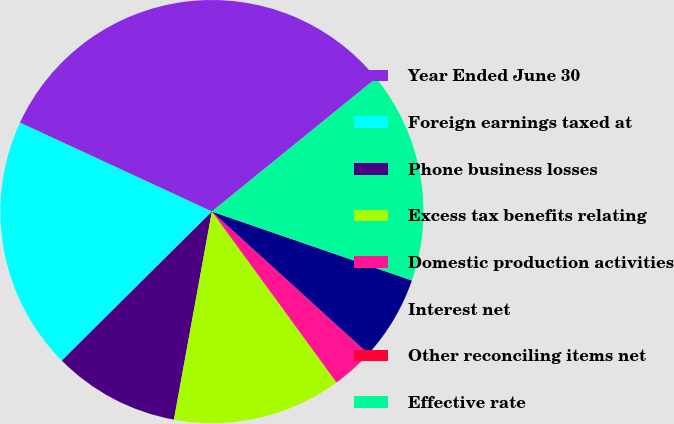<chart> <loc_0><loc_0><loc_500><loc_500><pie_chart><fcel>Year Ended June 30<fcel>Foreign earnings taxed at<fcel>Phone business losses<fcel>Excess tax benefits relating<fcel>Domestic production activities<fcel>Interest net<fcel>Other reconciling items net<fcel>Effective rate<nl><fcel>32.25%<fcel>19.35%<fcel>9.68%<fcel>12.9%<fcel>3.23%<fcel>6.46%<fcel>0.01%<fcel>16.13%<nl></chart> 